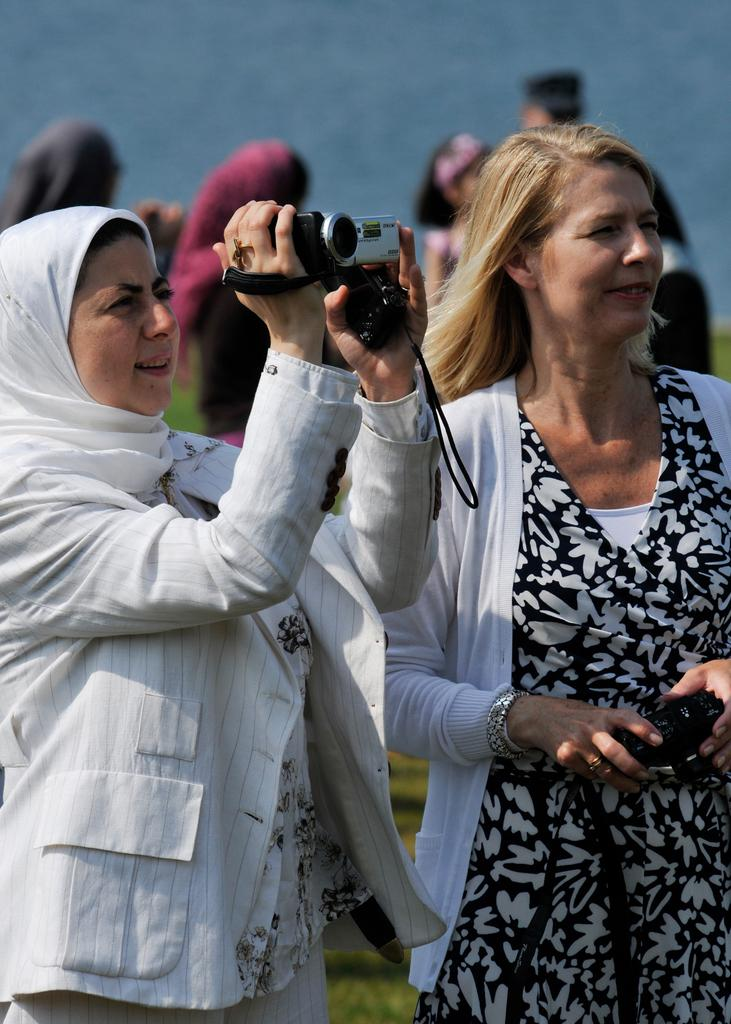What is the woman on the left side of the image doing? The woman on the left is recording a video. What is the woman on the right side of the image holding? The woman on the right is holding a camera. Can you describe the people in the background of the image? There are people in the background of the image, but no specific details are provided about them. What type of comfort can be seen in the image? There is no specific comfort item or feature present in the image. Is it a hot day in the image? The provided facts do not mention the weather or temperature, so it cannot be determined if it is a hot day in the image. 